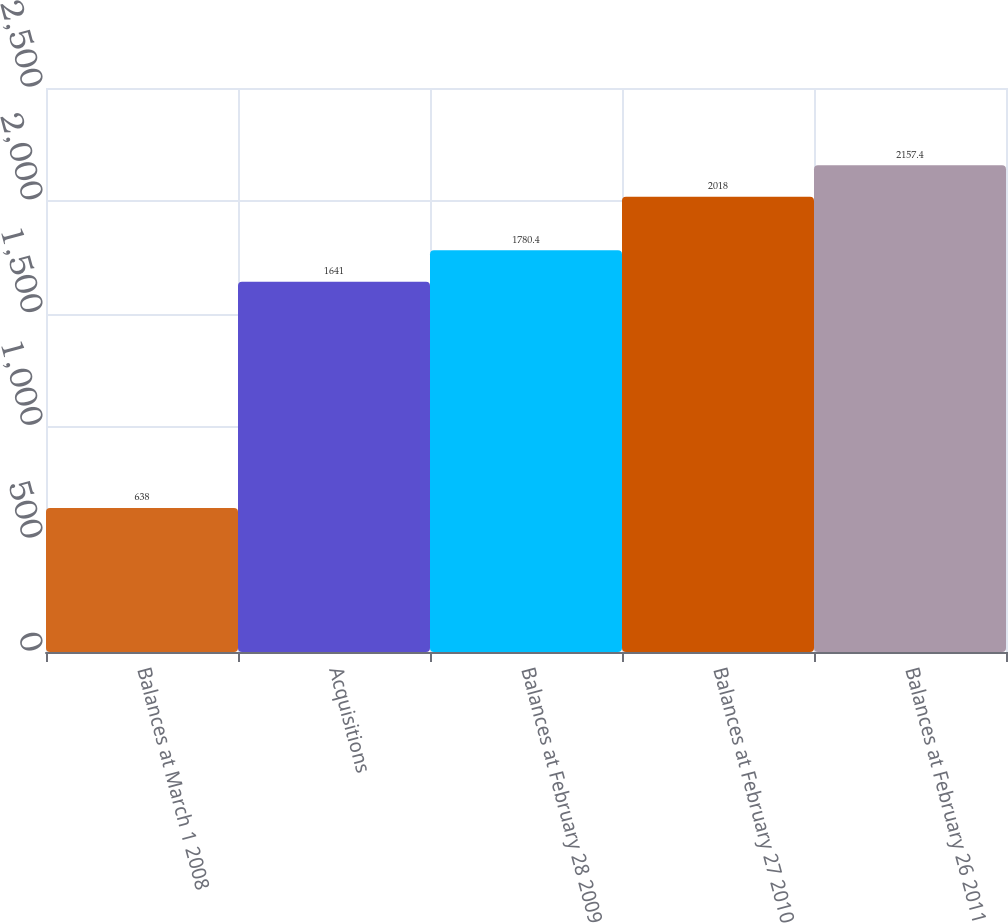Convert chart. <chart><loc_0><loc_0><loc_500><loc_500><bar_chart><fcel>Balances at March 1 2008<fcel>Acquisitions<fcel>Balances at February 28 2009<fcel>Balances at February 27 2010<fcel>Balances at February 26 2011<nl><fcel>638<fcel>1641<fcel>1780.4<fcel>2018<fcel>2157.4<nl></chart> 